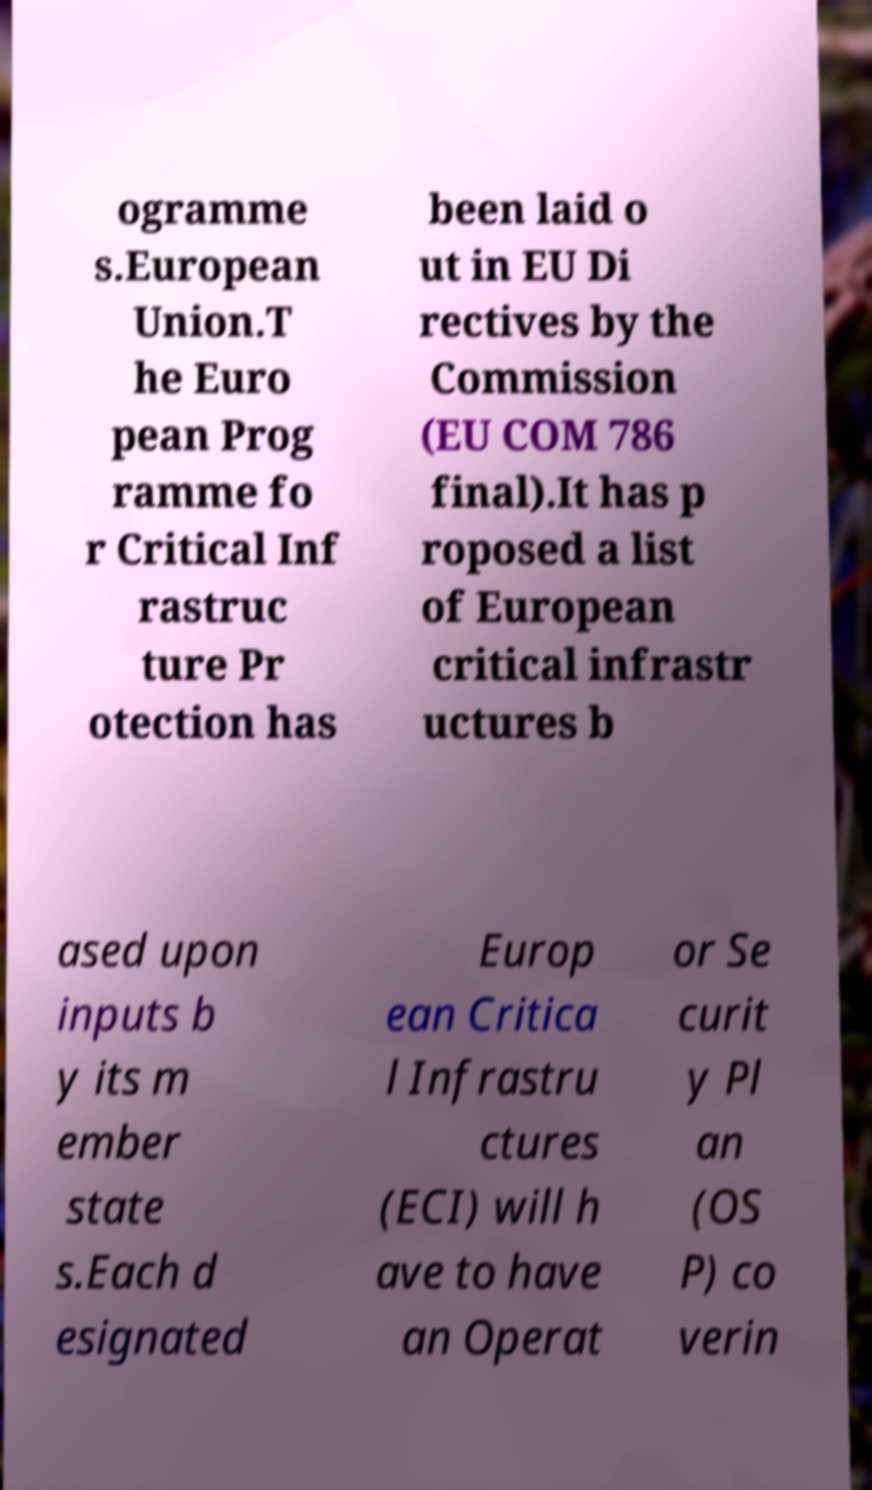Could you extract and type out the text from this image? ogramme s.European Union.T he Euro pean Prog ramme fo r Critical Inf rastruc ture Pr otection has been laid o ut in EU Di rectives by the Commission (EU COM 786 final).It has p roposed a list of European critical infrastr uctures b ased upon inputs b y its m ember state s.Each d esignated Europ ean Critica l Infrastru ctures (ECI) will h ave to have an Operat or Se curit y Pl an (OS P) co verin 